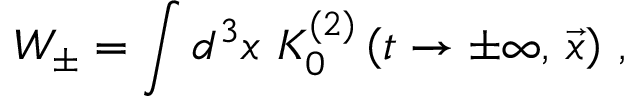Convert formula to latex. <formula><loc_0><loc_0><loc_500><loc_500>W _ { \pm } = \int d ^ { 3 } x \, K _ { 0 } ^ { ( 2 ) } \left ( t \to \pm \infty , \, { \vec { x } } \right ) \, ,</formula> 